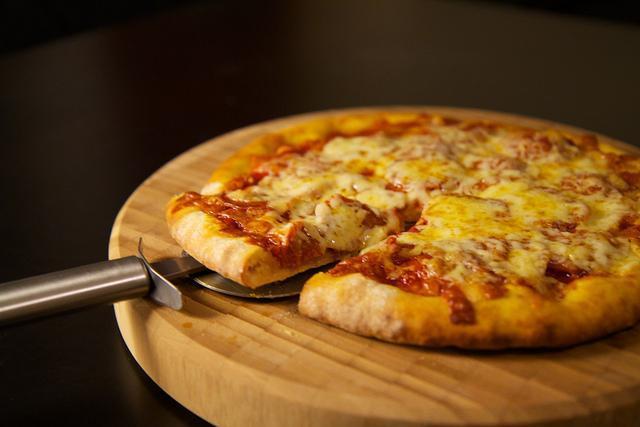How many giraffes are there in the grass?
Give a very brief answer. 0. 